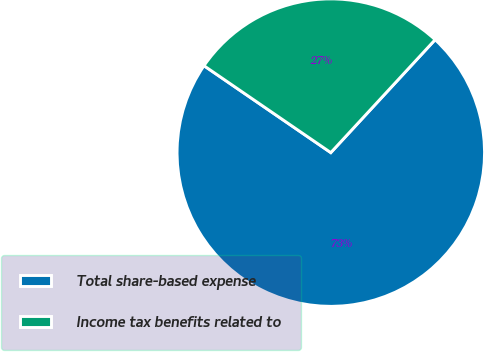Convert chart to OTSL. <chart><loc_0><loc_0><loc_500><loc_500><pie_chart><fcel>Total share-based expense<fcel>Income tax benefits related to<nl><fcel>72.69%<fcel>27.31%<nl></chart> 